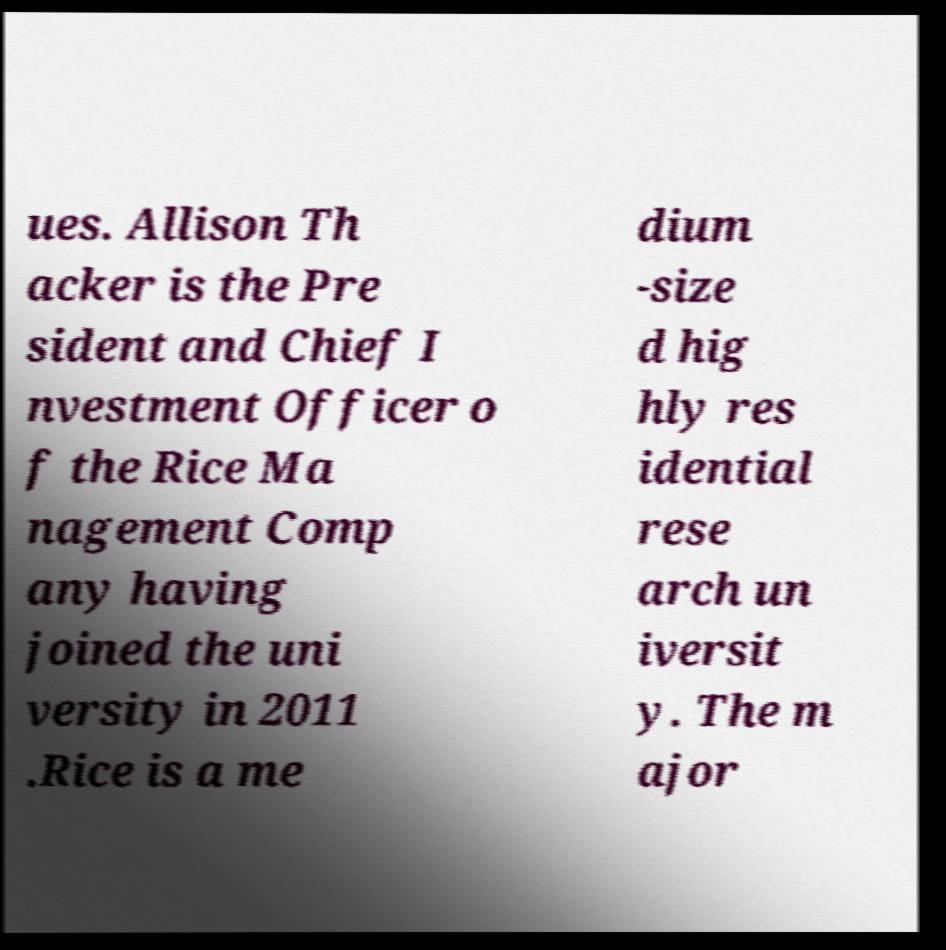I need the written content from this picture converted into text. Can you do that? ues. Allison Th acker is the Pre sident and Chief I nvestment Officer o f the Rice Ma nagement Comp any having joined the uni versity in 2011 .Rice is a me dium -size d hig hly res idential rese arch un iversit y. The m ajor 